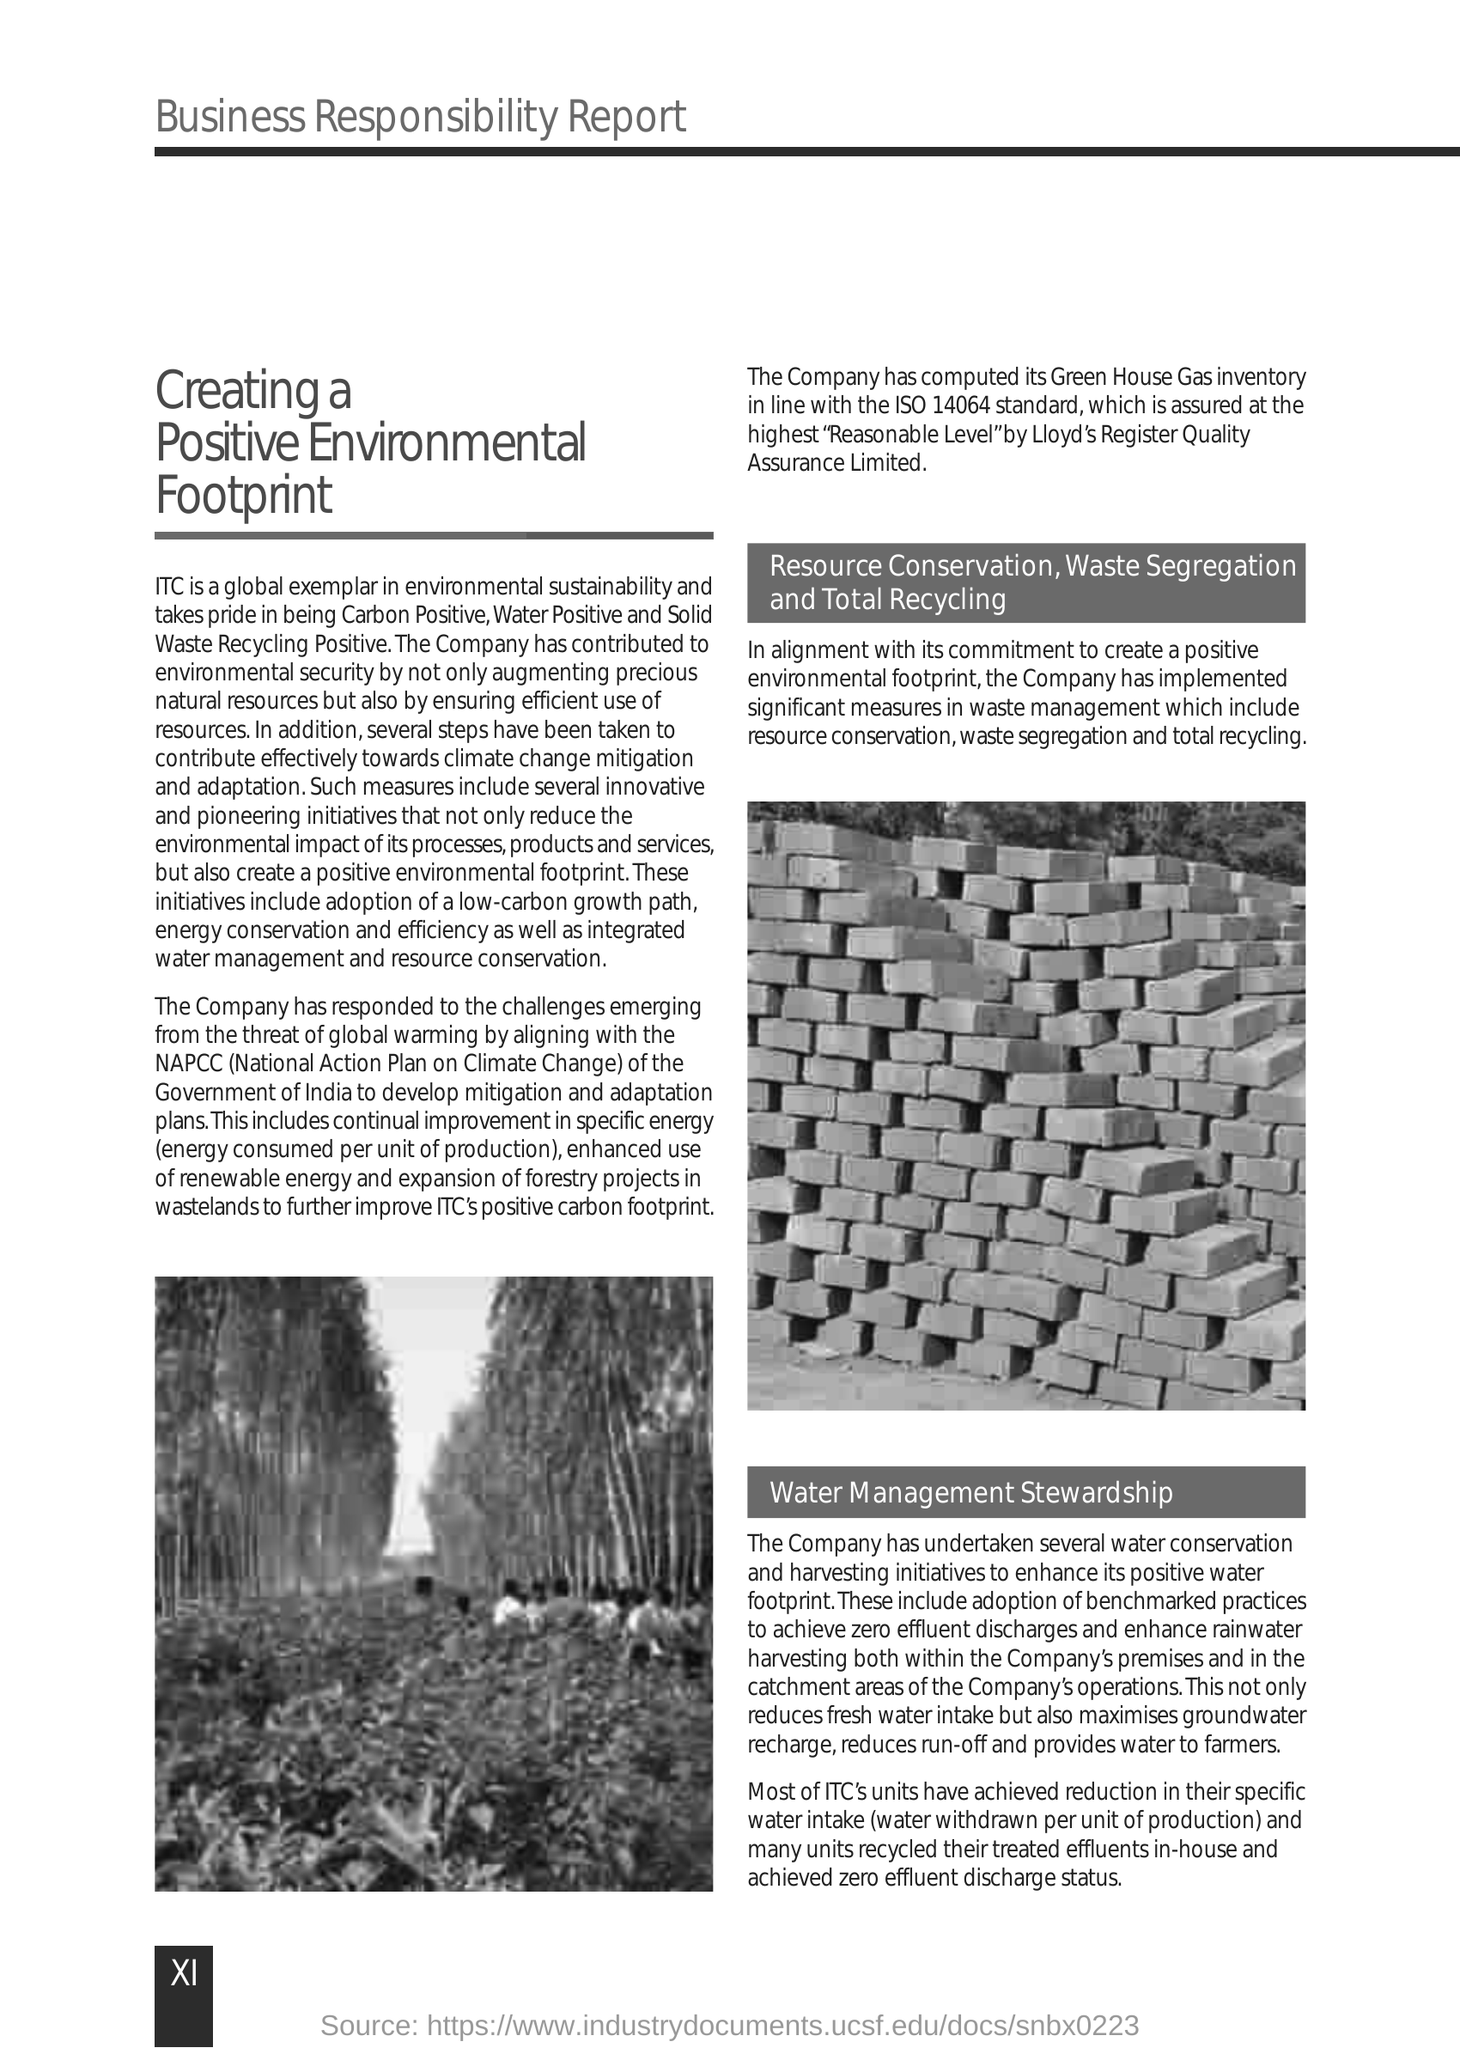Mention a couple of crucial points in this snapshot. The company has computed its Green House Gas inventory in accordance with the ISO 14064 standard. The National Action Plan on Climate Change, or NAPCC, is a comprehensive plan to address the impacts of climate change and to promote low-carbon, climate-resilient development in India. Specific water intake refers to the amount of water withdrawn per unit of production, providing a clear and concise understanding of the water usage in a particular industry or process. Specific energy refers to the amount of energy consumed per unit of production. 